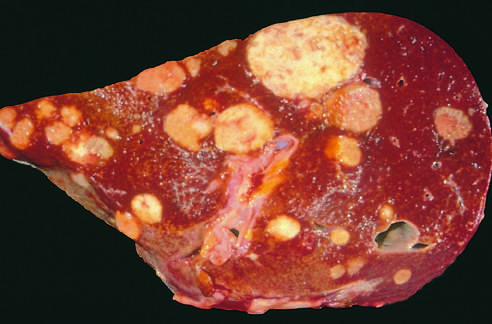what is studded with metastatic cancer?
Answer the question using a single word or phrase. A liver 